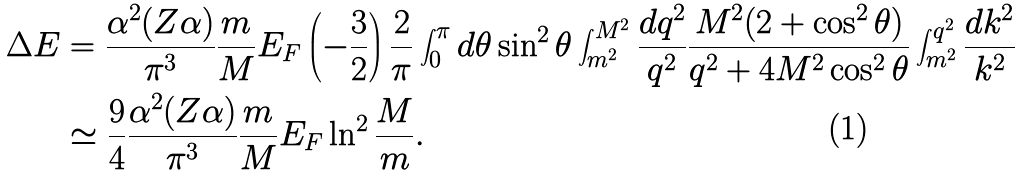<formula> <loc_0><loc_0><loc_500><loc_500>\Delta E & = \frac { \alpha ^ { 2 } ( Z \alpha ) } { \pi ^ { 3 } } \frac { m } { M } E _ { F } \left ( - \frac { 3 } { 2 } \right ) \frac { 2 } { \pi } \int _ { 0 } ^ { \pi } { d \theta } \sin ^ { 2 } { \theta } \int _ { m ^ { 2 } } ^ { M ^ { 2 } } \frac { d q ^ { 2 } } { q ^ { 2 } } \frac { M ^ { 2 } ( 2 + \cos ^ { 2 } { \theta } ) } { q ^ { 2 } + 4 M ^ { 2 } \cos ^ { 2 } { \theta } } \int _ { m ^ { 2 } } ^ { q ^ { 2 } } \frac { d k ^ { 2 } } { k ^ { 2 } } \\ & \simeq \frac { 9 } { 4 } \frac { \alpha ^ { 2 } ( Z \alpha ) } { \pi ^ { 3 } } \frac { m } { M } E _ { F } \ln ^ { 2 } { \frac { M } { m } } .</formula> 